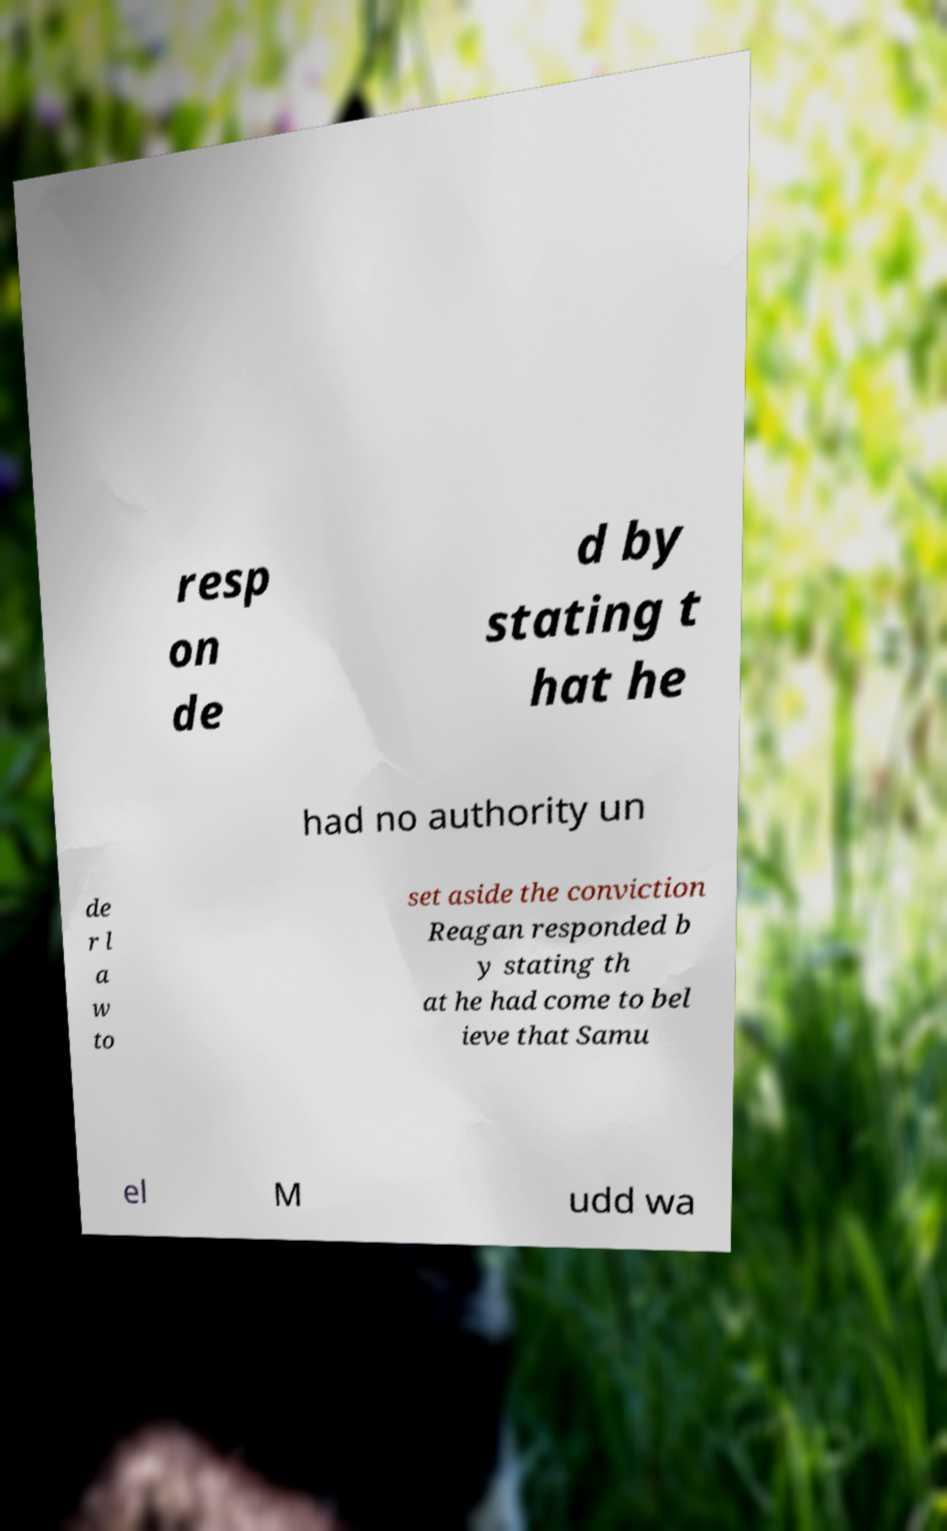Could you assist in decoding the text presented in this image and type it out clearly? resp on de d by stating t hat he had no authority un de r l a w to set aside the conviction Reagan responded b y stating th at he had come to bel ieve that Samu el M udd wa 